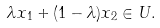<formula> <loc_0><loc_0><loc_500><loc_500>\lambda x _ { 1 } + ( 1 - \lambda ) x _ { 2 } \in U .</formula> 